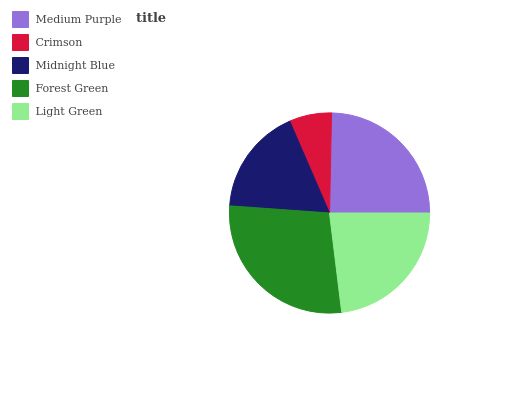Is Crimson the minimum?
Answer yes or no. Yes. Is Forest Green the maximum?
Answer yes or no. Yes. Is Midnight Blue the minimum?
Answer yes or no. No. Is Midnight Blue the maximum?
Answer yes or no. No. Is Midnight Blue greater than Crimson?
Answer yes or no. Yes. Is Crimson less than Midnight Blue?
Answer yes or no. Yes. Is Crimson greater than Midnight Blue?
Answer yes or no. No. Is Midnight Blue less than Crimson?
Answer yes or no. No. Is Light Green the high median?
Answer yes or no. Yes. Is Light Green the low median?
Answer yes or no. Yes. Is Crimson the high median?
Answer yes or no. No. Is Midnight Blue the low median?
Answer yes or no. No. 